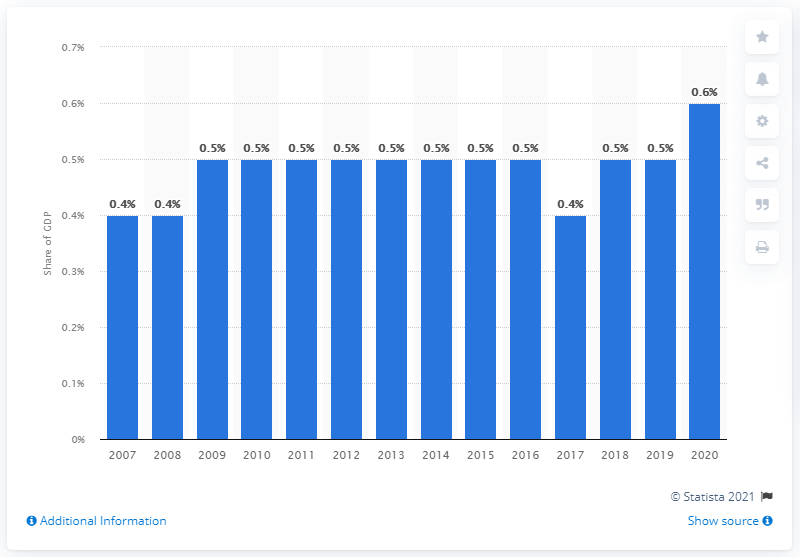Give some essential details in this illustration. In 2009, Mexico's military expenditure remained constant. In 2020, military expenditure accounted for approximately 0.6% of the country's Gross Domestic Product (GDP). Mexico's military expenditure dropped to 0.4% of its GDP in 2017. 